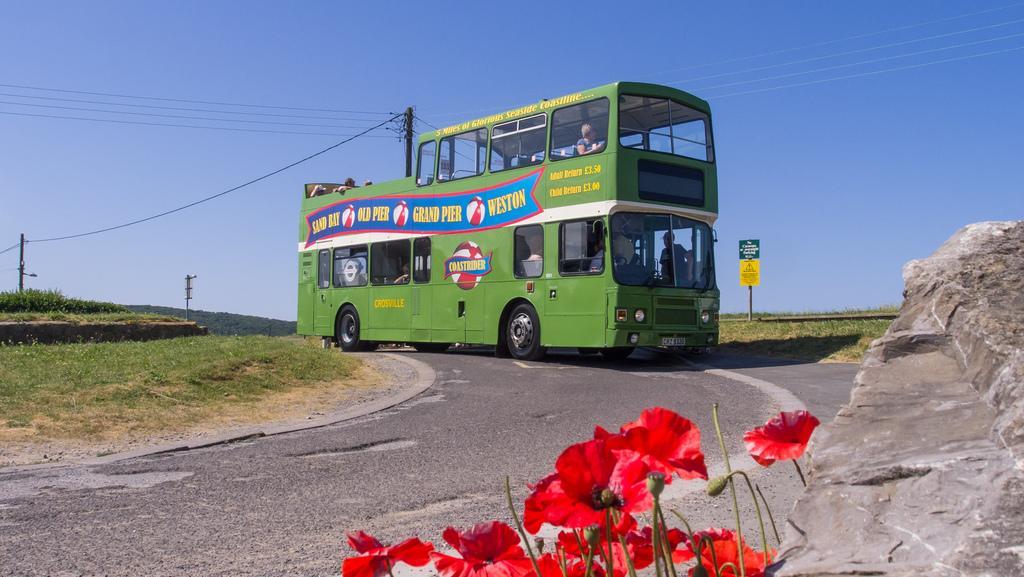How would you summarize this image in a sentence or two? In this picture there is a double-decker bus in the center of the image and there are flowers at the bottom side of the image and there is a rock on the right side of the image, there are poles, wires, and greenery in the background area of the image. 